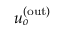<formula> <loc_0><loc_0><loc_500><loc_500>u _ { o } ^ { ( o u t ) }</formula> 